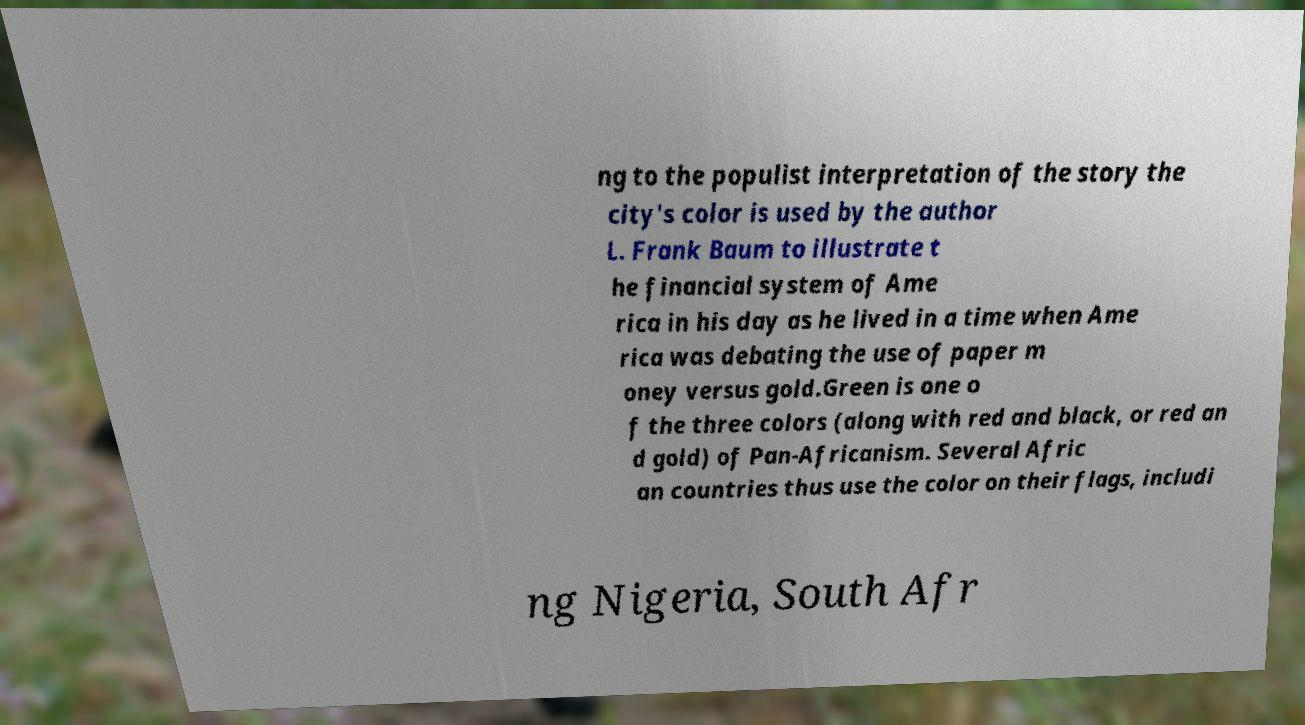I need the written content from this picture converted into text. Can you do that? ng to the populist interpretation of the story the city's color is used by the author L. Frank Baum to illustrate t he financial system of Ame rica in his day as he lived in a time when Ame rica was debating the use of paper m oney versus gold.Green is one o f the three colors (along with red and black, or red an d gold) of Pan-Africanism. Several Afric an countries thus use the color on their flags, includi ng Nigeria, South Afr 